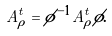<formula> <loc_0><loc_0><loc_500><loc_500>A ^ { t } _ { \tilde { \rho } } = \phi ^ { - 1 } A ^ { t } _ { \rho } \phi .</formula> 